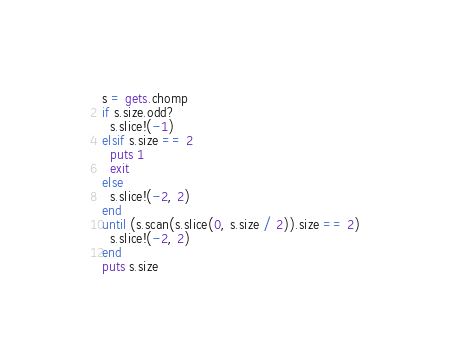<code> <loc_0><loc_0><loc_500><loc_500><_Ruby_>s = gets.chomp
if s.size.odd?
  s.slice!(-1)
elsif s.size == 2
  puts 1
  exit
else
  s.slice!(-2, 2)
end
until (s.scan(s.slice(0, s.size / 2)).size == 2)
  s.slice!(-2, 2)
end
puts s.size</code> 